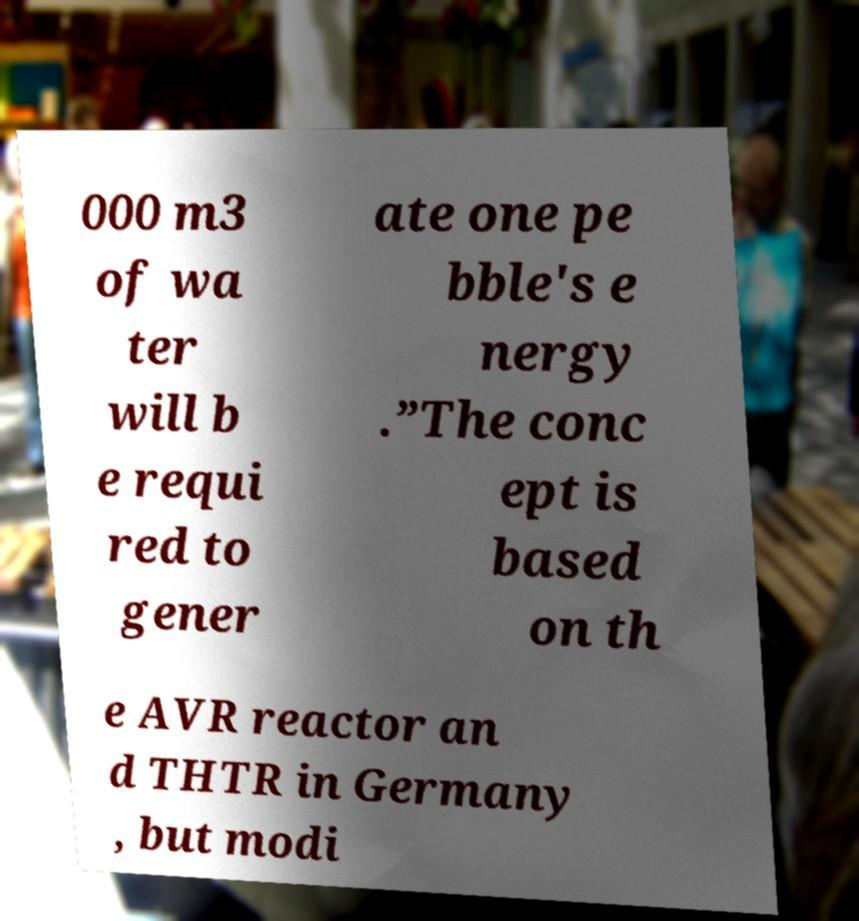Could you assist in decoding the text presented in this image and type it out clearly? 000 m3 of wa ter will b e requi red to gener ate one pe bble's e nergy .”The conc ept is based on th e AVR reactor an d THTR in Germany , but modi 